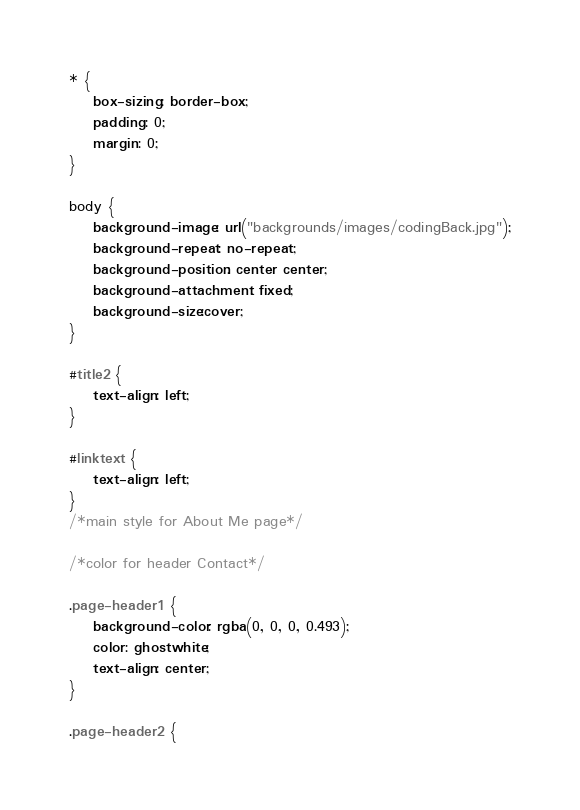Convert code to text. <code><loc_0><loc_0><loc_500><loc_500><_CSS_>* {
    box-sizing: border-box;
    padding: 0;
    margin: 0;
}

body {
    background-image: url("backgrounds/images/codingBack.jpg");
    background-repeat: no-repeat;
    background-position: center center;
    background-attachment: fixed;
    background-size:cover;
}

#title2 {
    text-align: left;
}
 
#linktext {
    text-align: left;
}
/*main style for About Me page*/

/*color for header Contact*/

.page-header1 {
    background-color: rgba(0, 0, 0, 0.493);
    color: ghostwhite;
    text-align: center;
}

.page-header2 {</code> 